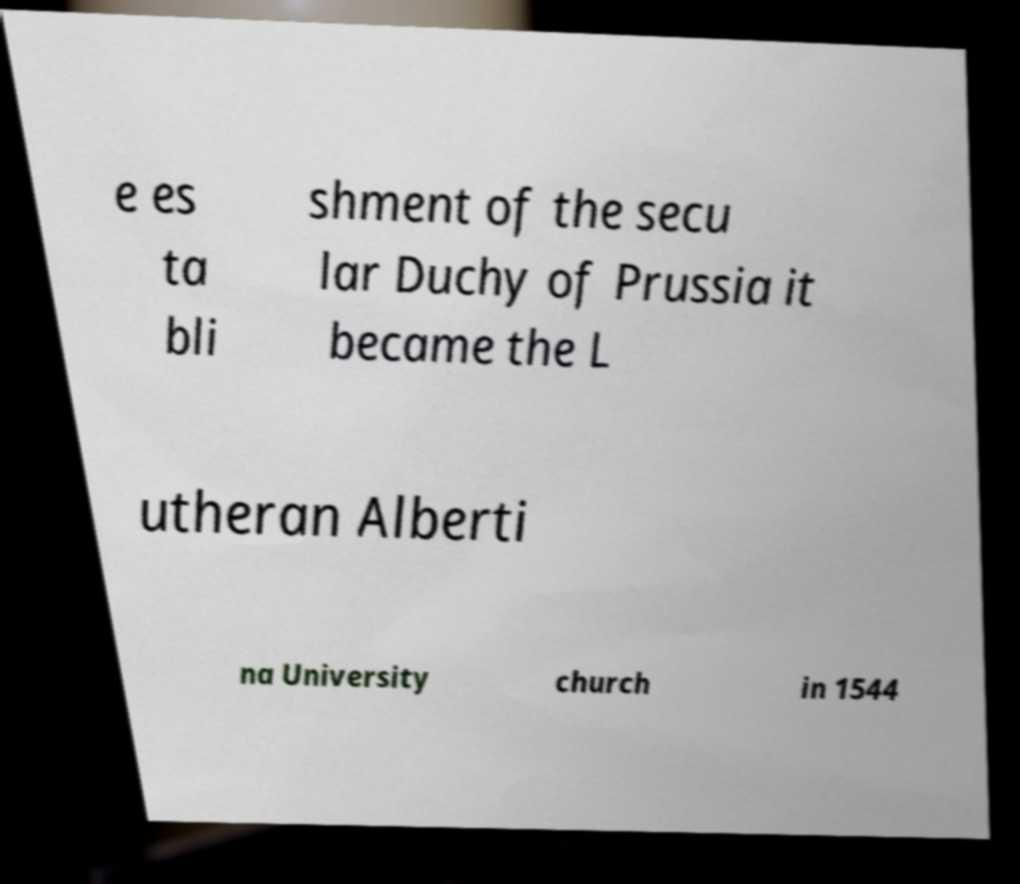I need the written content from this picture converted into text. Can you do that? e es ta bli shment of the secu lar Duchy of Prussia it became the L utheran Alberti na University church in 1544 